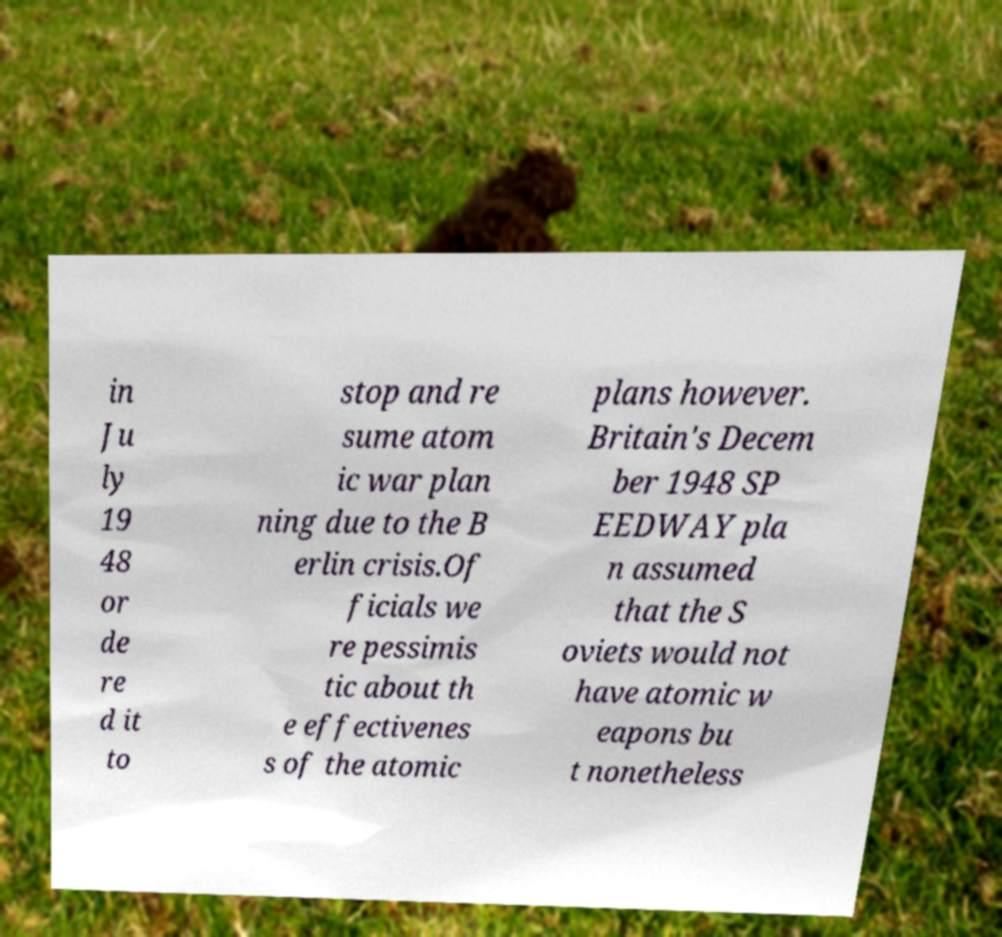I need the written content from this picture converted into text. Can you do that? in Ju ly 19 48 or de re d it to stop and re sume atom ic war plan ning due to the B erlin crisis.Of ficials we re pessimis tic about th e effectivenes s of the atomic plans however. Britain's Decem ber 1948 SP EEDWAY pla n assumed that the S oviets would not have atomic w eapons bu t nonetheless 